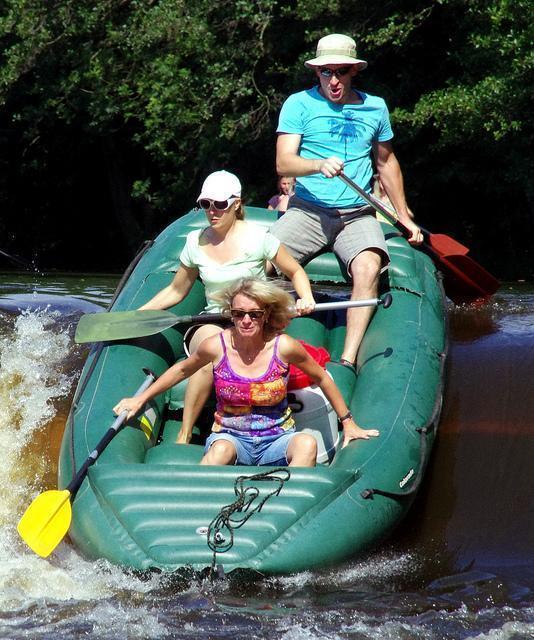What type of boat are they navigating the water on?
Pick the right solution, then justify: 'Answer: answer
Rationale: rationale.'
Options: Fishing, raft, canoe, kayak. Answer: raft.
Rationale: They are in an inflatable boat used for navigating white waters. option a matches the name for such a boat. 